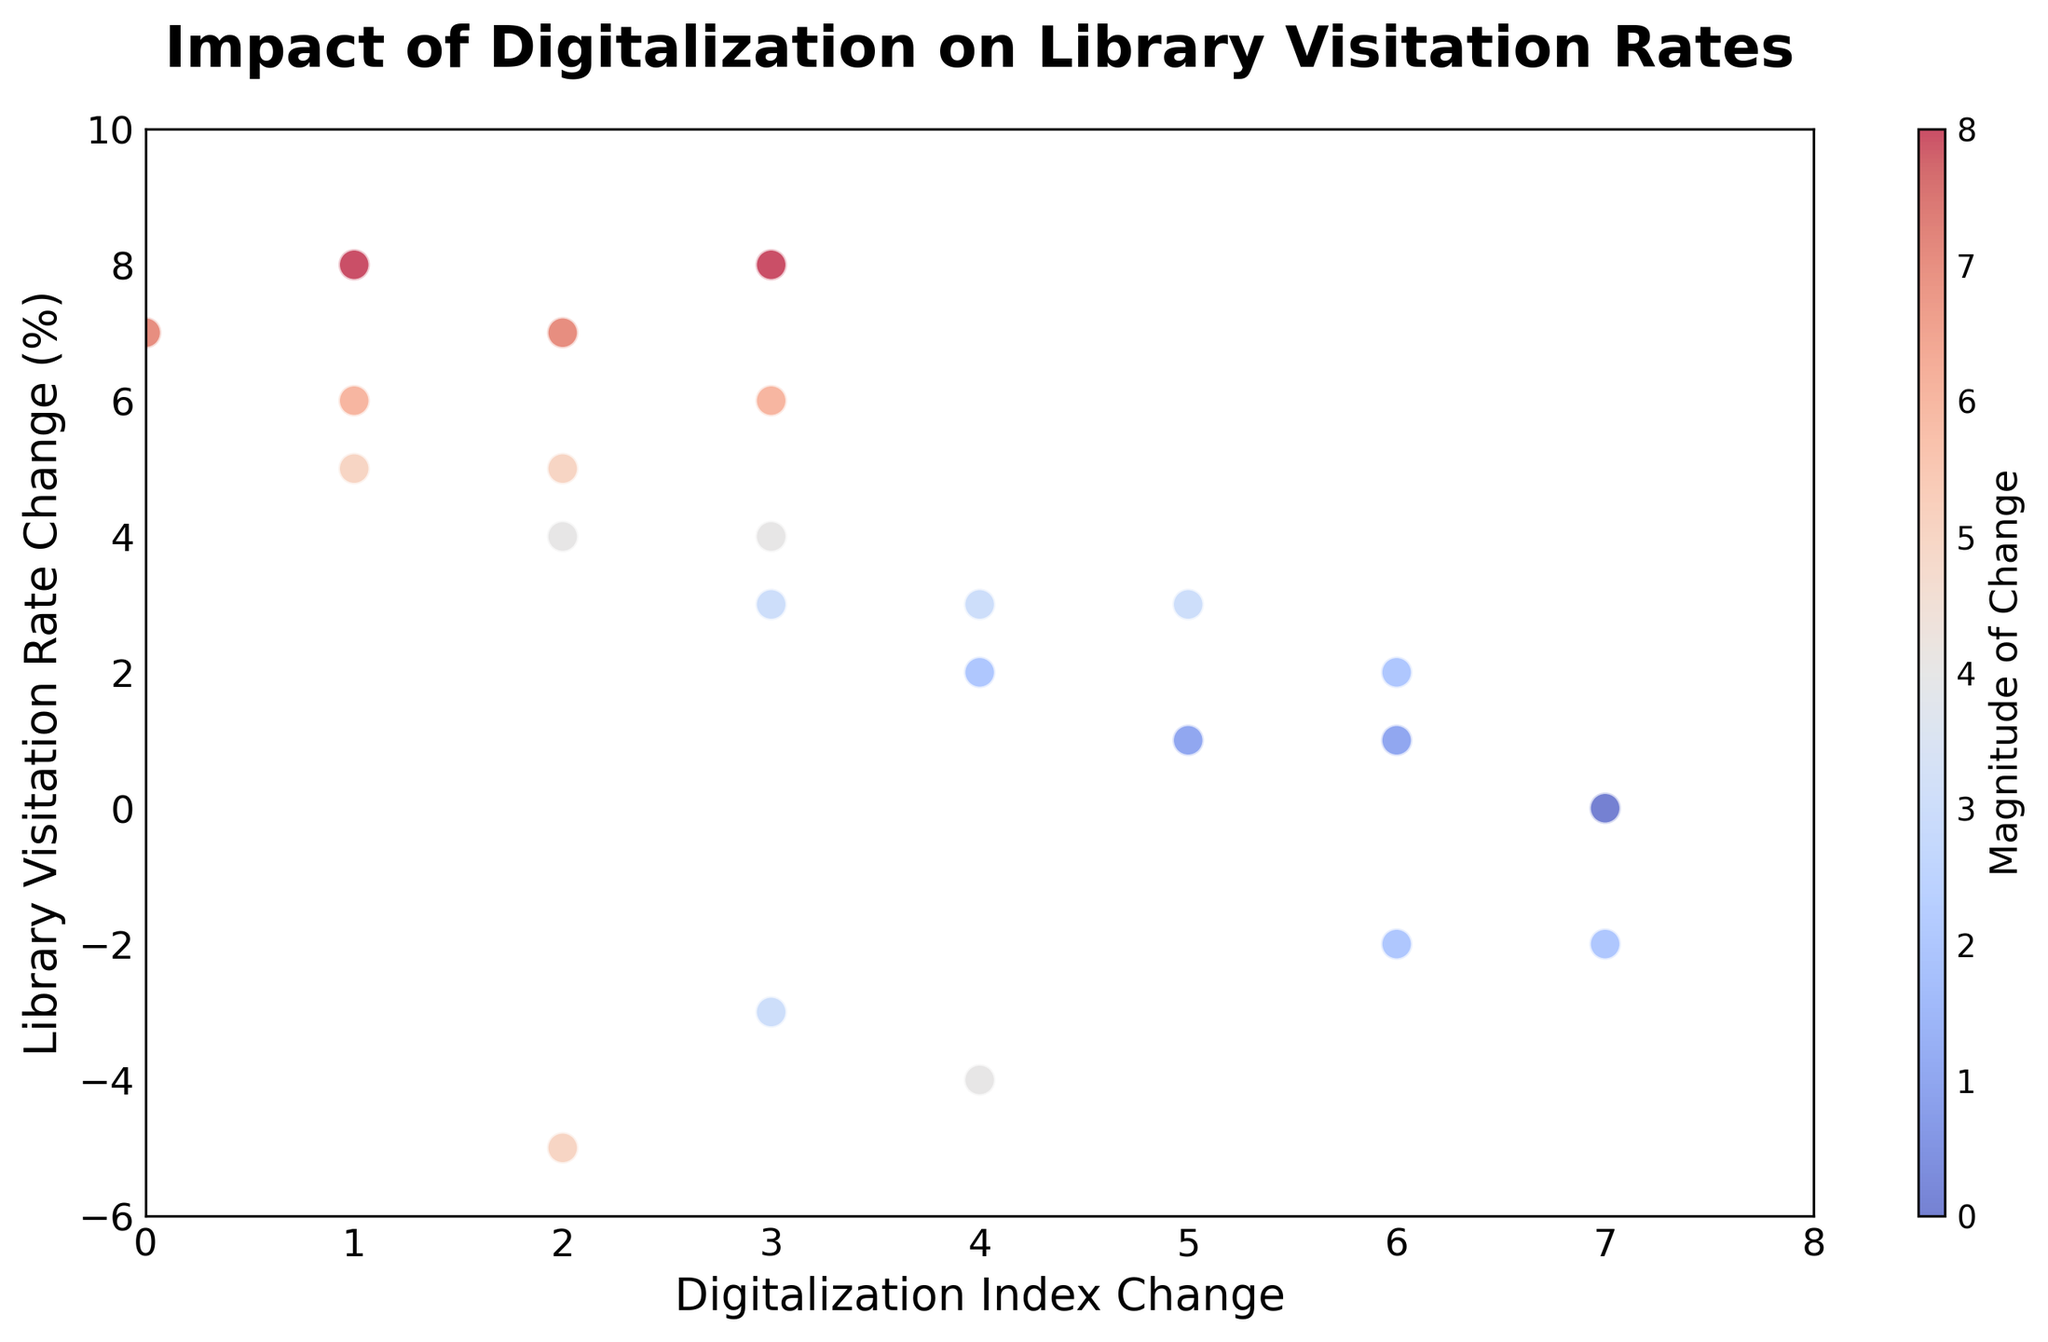What's the trend between Digitalization Index Change and Library Visitation Rate Change shown in the plot? To determine the trend, observe how the library visitation rate changes as the digitalization index changes. It seems that as the digitalization index increases, especially in the earlier years, there is a decline in library visitation rates. However, over time, even with digitalization increasing or stabilizing, the library visitation rate shifts to positive changes, indicating an initial negative impact followed by adaptation and improved visitation rates.
Answer: Initial negative impact, then positive change What years had the most significant decrease in Library Visitation Rate Change? The most significant decreases in library visitation rates are reflected by the data points in the lower part of the plot. Specifically, in the years 2000, 2001, and 2002, the library visitation rate change is -5%, -3%, and -4%, respectively. The lowest point is in the year 2000 at -5%.
Answer: 2000 Which year had the highest Library Visitation Rate Change, and what was the Digitalization Index Change in that year? Look for the highest data point on the scatter plot. The highest Library Visitation Rate Change is 8%, occurring in the year 2019. In that year, the corresponding Digitalization Index Change is 1.
Answer: 2019, 1 How many years experienced a positive Library Visitation Rate Change? Count the number of points above the 0% line for Library Visitation Rate Change. This includes points where values are positive. Counting these points, there are 12 years with positive Library Visitation Rate Changes.
Answer: 12 years What's the average change in Digitalization Index for the years with a positive change in Library Visitation Rate? First, identify the years with positive Library Visitation Rate Change: from 2006 to 2022. Sum up the Digitalization Index Changes for these 12 years: (6 + 6 + 5 + 5 + 4 + 4 + 3 + 3 + 2 + 2 + 1 + 1) = 42. Then, divide by the number of years: 42 / 12 = 3.5.
Answer: 3.5 Compare the Library Visitation Rate Change in 2010 and 2012. Which one is higher and by how much? Look at the graph for the values in 2010 and 2012. In 2010, the Library Visitation Rate Change is 3%, and in 2012, it is 4%. Subtract the 2010 value from the 2012 value: 4% - 3% = 1%.
Answer: 2012 by 1% In which color range on the color bar do most of the data points fall? Looking at the scatter plot and color bar, observe which colors appear most frequently among data points. Most data points are colored in shades between lighter blue to darker red, indicating they mostly fall around the middle range, corresponding to moderate changes.
Answer: Middle range What is the relationship between Digitalization Index Change and Library Visitation Rate Change as indicated by the color bar? The color bar reflects the magnitude of the changes. Larger absolute changes are represented by more intense colors. Therefore, a more significant change, whether increase or decrease, will appear more vividly colored, indicating the magnitude of impact.
Answer: Larger changes are more vividly colored Which years had a 0% change in Library Visitation Rate and what was the Digitalization Index Change in that year? For the year with a 0% Library Visitation Rate Change, look for the point on the scatter plot that lies on the 0% line. In the year 2005, there was a 0% Library Visitation Rate Change with a Digitalization Index Change of 7.
Answer: 2005, 7 